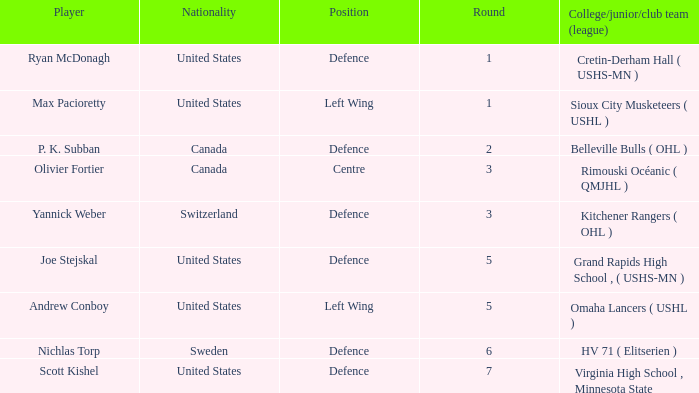Which player from the United States plays defence and was chosen before round 5? Ryan McDonagh. 